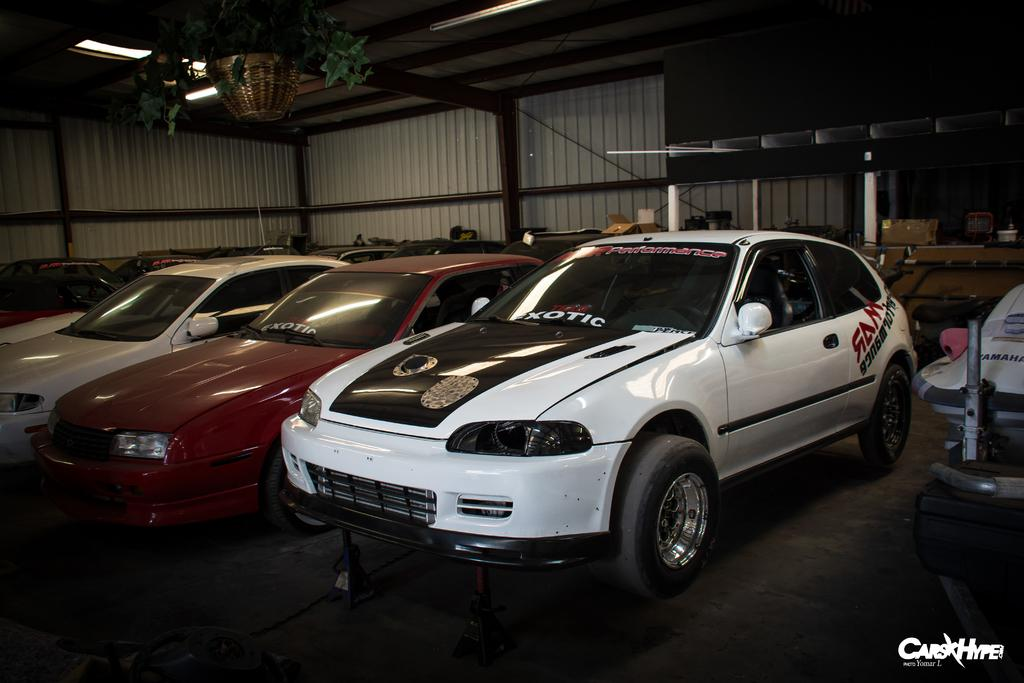What type of vehicles can be seen in the image? There are cars in the image. Can you describe the appearance of the cars? The cars are in different colors. What can be seen in the background of the image? There are objects, poles, and a shed visible in the background. Is there any additional decorative element in the front of the image? Yes, there is a flower pot in the front of the image. What type of treatment is the writer receiving for their injuries in the image? There is no writer or injuries present in the image; it features cars, objects, poles, a shed, and a flower pot. How many horses are visible in the image? There are no horses present in the image. 